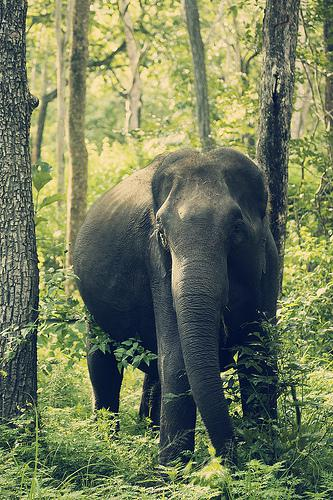Question: what type of animal is in the picture?
Choices:
A. An Tiger.
B. An elephant.
C. A Lion.
D. A bear.
Answer with the letter. Answer: B Question: how many humans are in the picture?
Choices:
A. Three.
B. Four.
C. Zero.
D. Five.
Answer with the letter. Answer: C Question: what color is the elephant?
Choices:
A. Grey.
B. Tan.
C. Brown.
D. Dark gray.
Answer with the letter. Answer: A 